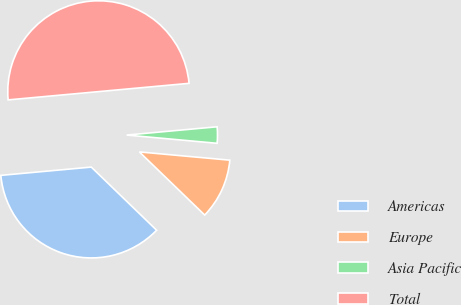Convert chart. <chart><loc_0><loc_0><loc_500><loc_500><pie_chart><fcel>Americas<fcel>Europe<fcel>Asia Pacific<fcel>Total<nl><fcel>36.32%<fcel>10.78%<fcel>2.9%<fcel>50.0%<nl></chart> 